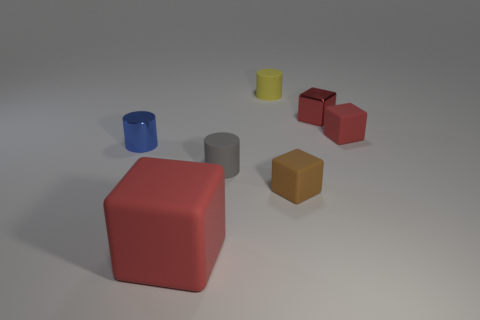Subtract all gray spheres. How many red cubes are left? 3 Subtract all blue blocks. Subtract all cyan cylinders. How many blocks are left? 4 Add 1 red things. How many objects exist? 8 Subtract all cubes. How many objects are left? 3 Subtract all yellow matte objects. Subtract all brown matte things. How many objects are left? 5 Add 5 small blue cylinders. How many small blue cylinders are left? 6 Add 4 blue cubes. How many blue cubes exist? 4 Subtract 0 gray spheres. How many objects are left? 7 